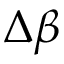<formula> <loc_0><loc_0><loc_500><loc_500>\Delta \beta</formula> 